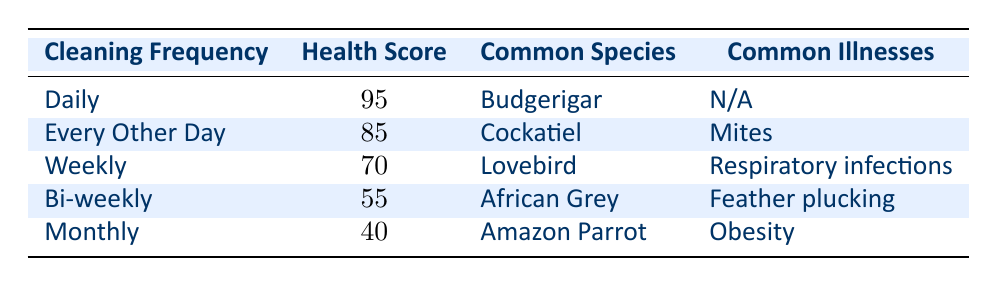What is the average bird health score for daily cleaning? The table shows that the average bird health score for daily cleaning is 95.
Answer: 95 Which bird species is most commonly associated with bi-weekly cleaning? According to the table, the most common bird species for bi-weekly cleaning is the African Grey.
Answer: African Grey How many points lower is the average health score for weekly cleaning compared to daily cleaning? The average health score for daily cleaning is 95 and for weekly cleaning is 70. The difference is 95 - 70 = 25 points.
Answer: 25 Are there common illnesses reported for birds cleaned daily? The table indicates that there are no common illnesses reported (N/A) for birds cleaned daily.
Answer: No What is the average bird health score across all cleaning frequencies? The health scores are 95, 85, 70, 55, and 40. The sum is (95 + 85 + 70 + 55 + 40) = 435. There are 5 frequencies, so the average is 435 / 5 = 87.
Answer: 87 Which cleaning frequency has the lowest average bird health score? The table shows that monthly cleaning has the lowest average bird health score, which is 40.
Answer: Monthly Is the average health score for every other day cleaning higher than that for monthly cleaning? The average health score for every other day cleaning is 85, while for monthly cleaning, it’s 40. Since 85 is greater than 40, the statement is true.
Answer: Yes What bird species is typically found with the highest average health score? Reviewing the table, the average health score of 95, associated with the Budgerigar, is the highest.
Answer: Budgerigar By how much does the average health score for every other day cleaning surpass that of weekly cleaning? The average health score for every other day cleaning is 85, while for weekly, it is 70. The difference is 85 - 70 = 15.
Answer: 15 